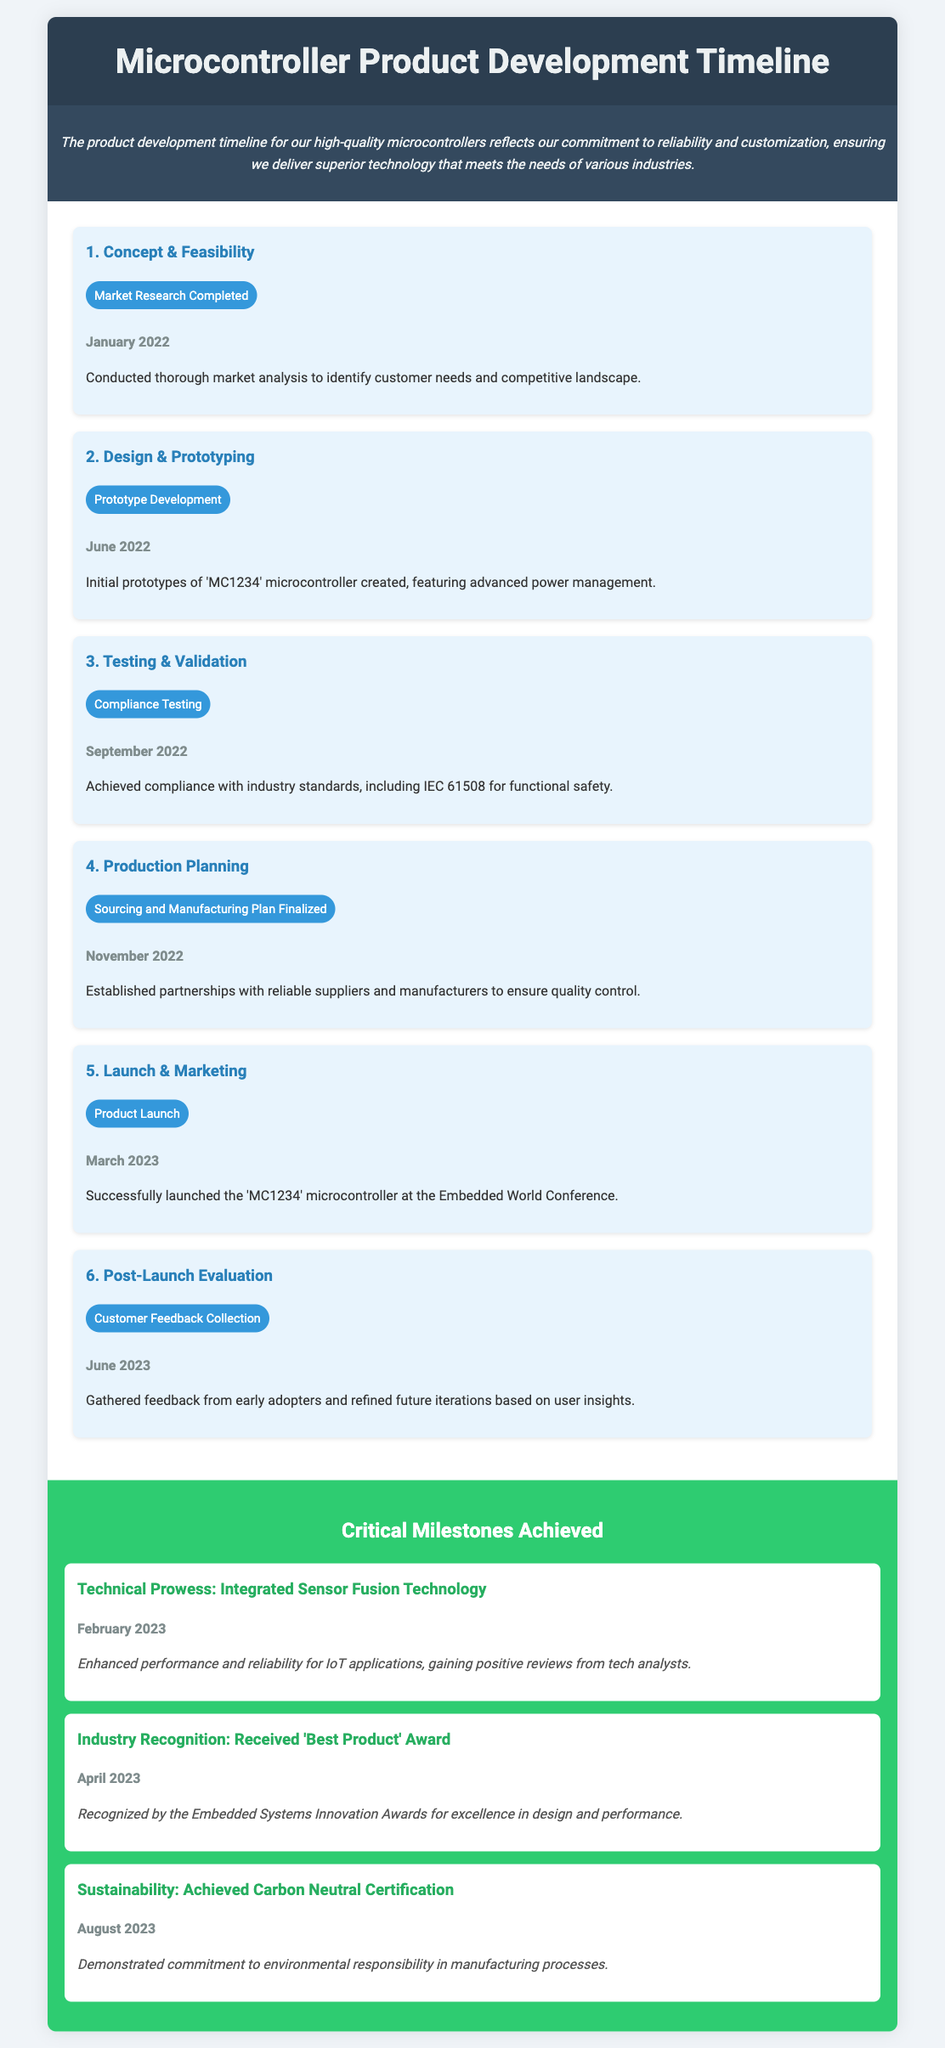What was the market research completion date? The market research completion date is provided in the first phase of the timeline.
Answer: January 2022 What is the name of the microcontroller launched? The name of the microcontroller is stated in the product launch milestone.
Answer: MC1234 How many critical milestones are achieved? The number of critical milestones is indicated in the section title.
Answer: Three When was the compliance testing milestone reached? The compliance testing milestone date can be found in the third phase of development.
Answer: September 2022 What technology was integrated into the microcontroller? The integrated technology is detailed in the first critical milestone description.
Answer: Sensor Fusion Technology Which award was received by the product? The award received is specified in the second critical milestone section.
Answer: Best Product Award What was the focus of the customer feedback collection milestone? The focus of the milestone is mentioned in the description of the last phase in the timeline.
Answer: User insights When was the product launched at the conference? The product launch date is given in the fifth phase of the timeline.
Answer: March 2023 What certification was achieved for sustainability? The certification is mentioned in the last critical milestone.
Answer: Carbon Neutral Certification 